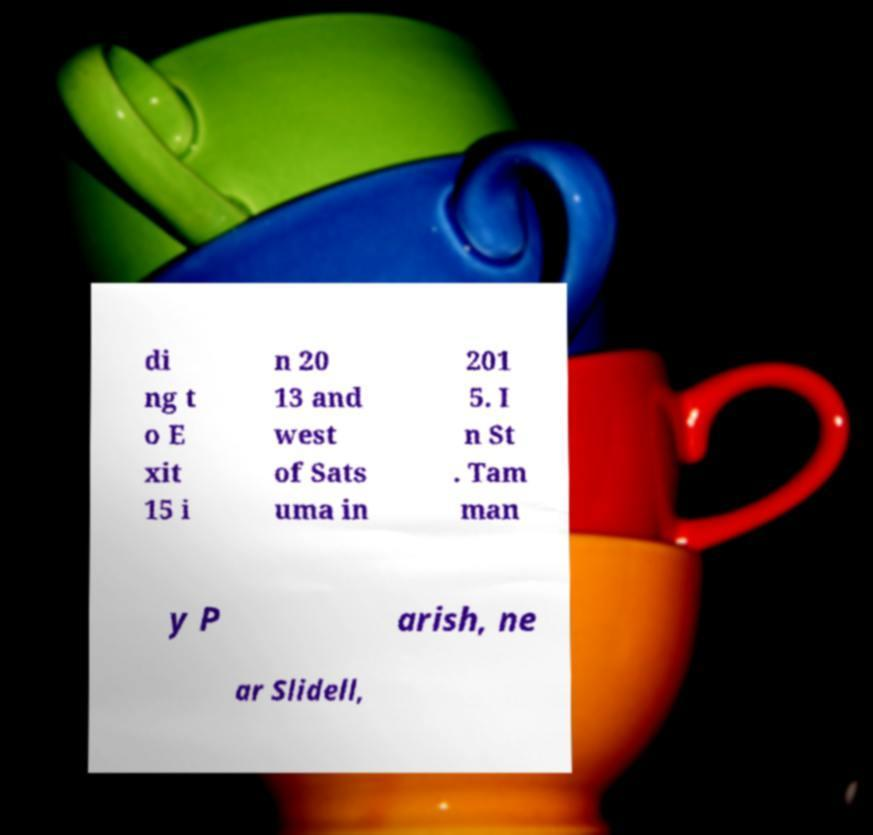Could you assist in decoding the text presented in this image and type it out clearly? di ng t o E xit 15 i n 20 13 and west of Sats uma in 201 5. I n St . Tam man y P arish, ne ar Slidell, 